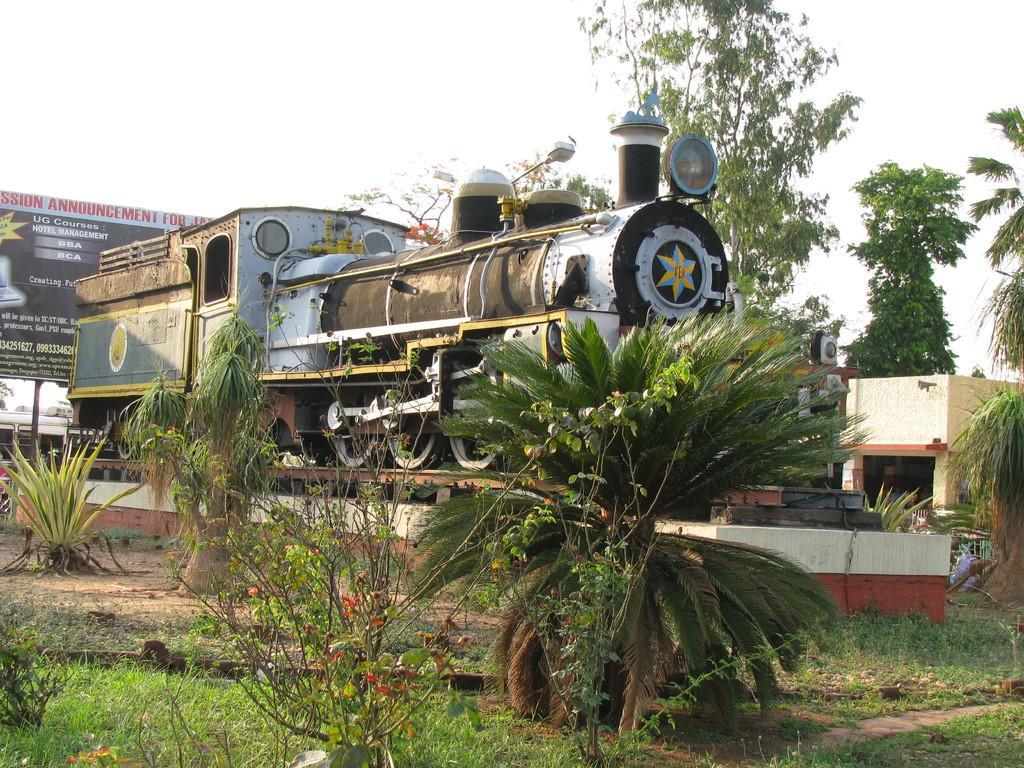Please provide a concise description of this image. In this picture there is a train on the railway track. At the back there is a building and there is a hoarding and there is text on the hoarding and there are trees and plants. At the top there is sky. At the bottom there is grass and there is ground. 